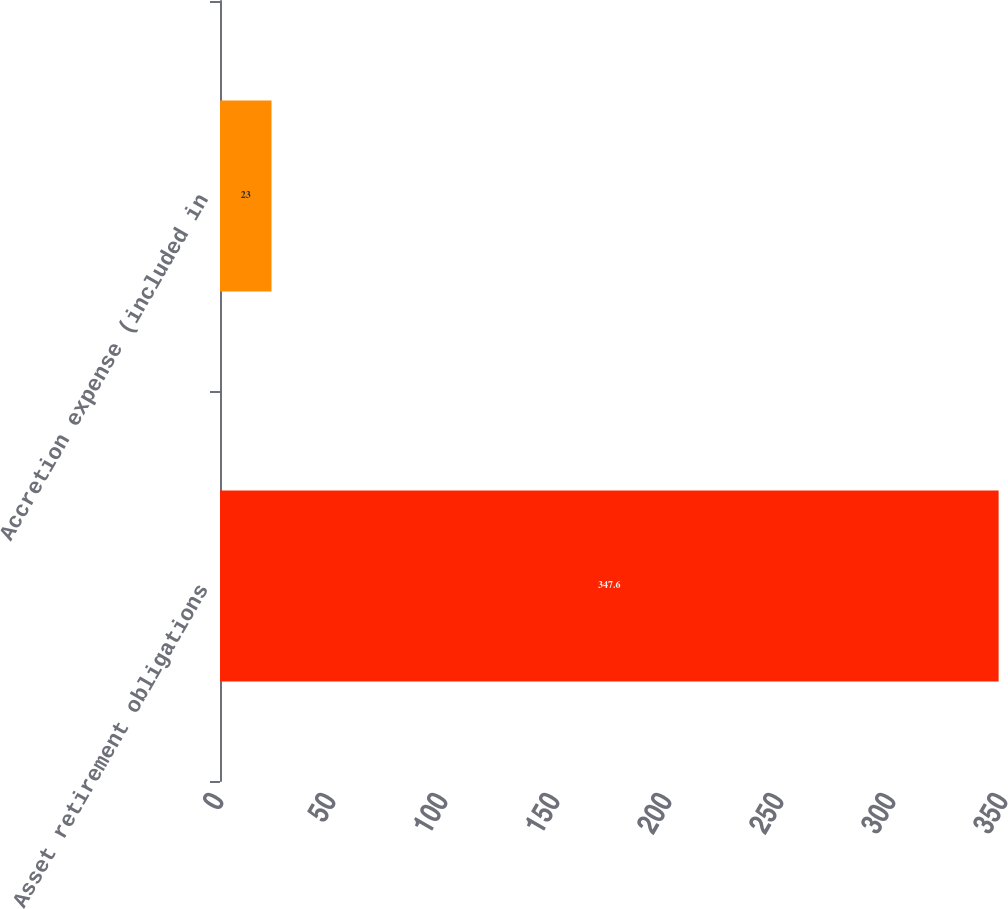<chart> <loc_0><loc_0><loc_500><loc_500><bar_chart><fcel>Asset retirement obligations<fcel>Accretion expense (included in<nl><fcel>347.6<fcel>23<nl></chart> 